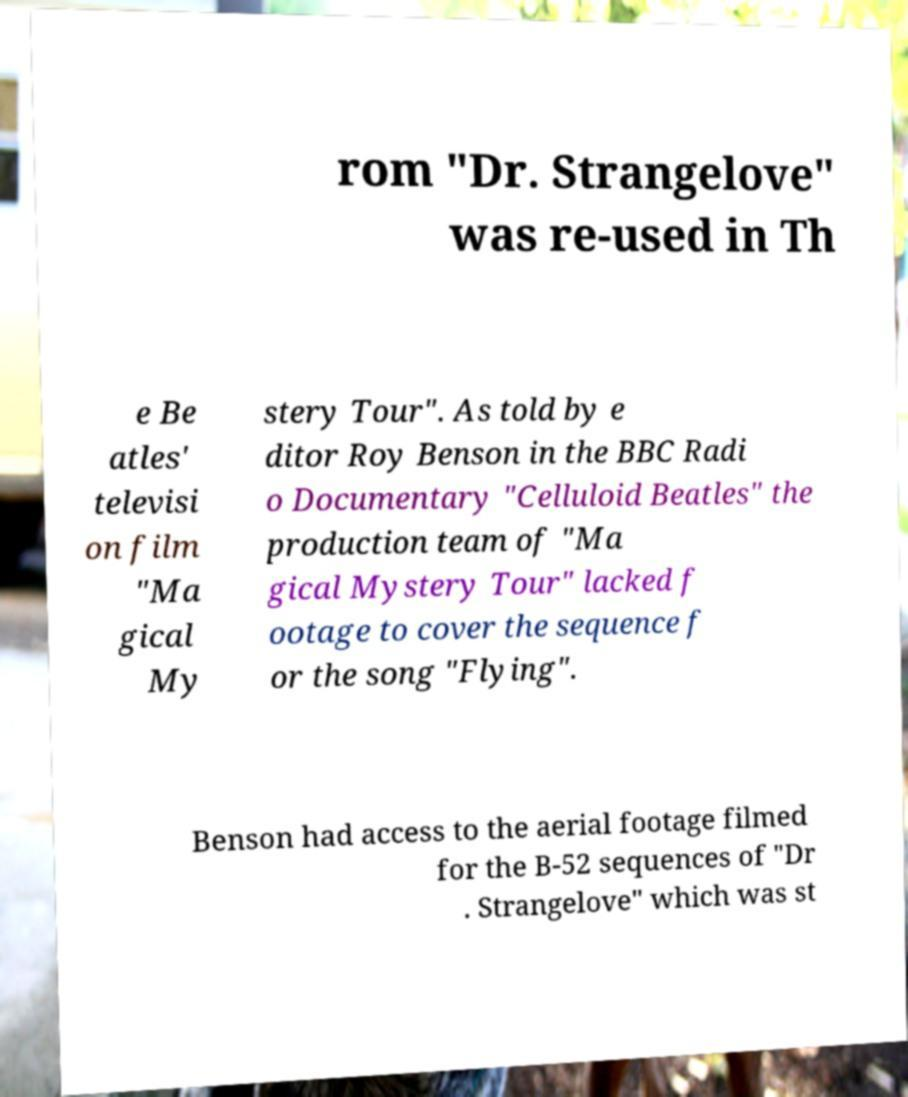I need the written content from this picture converted into text. Can you do that? rom "Dr. Strangelove" was re-used in Th e Be atles' televisi on film "Ma gical My stery Tour". As told by e ditor Roy Benson in the BBC Radi o Documentary "Celluloid Beatles" the production team of "Ma gical Mystery Tour" lacked f ootage to cover the sequence f or the song "Flying". Benson had access to the aerial footage filmed for the B-52 sequences of "Dr . Strangelove" which was st 